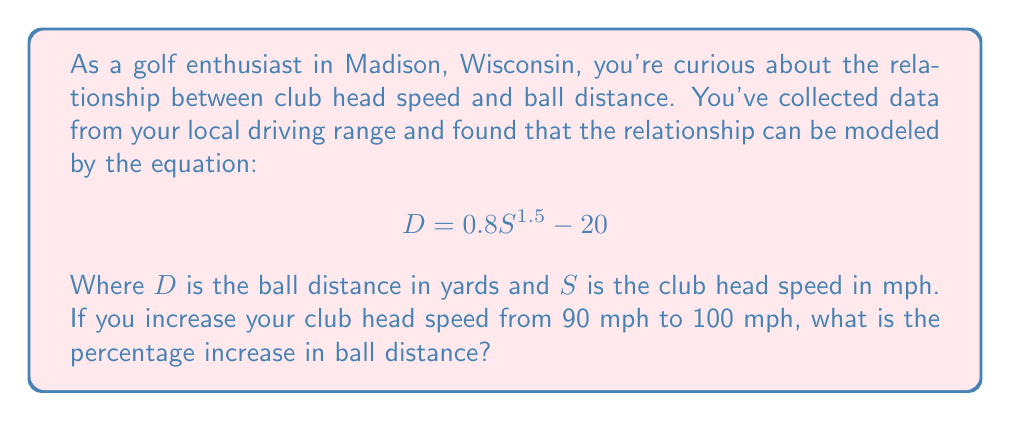Can you solve this math problem? Let's approach this step-by-step:

1) First, we need to calculate the ball distance for both speeds using the given equation:

   For 90 mph: $D_1 = 0.8(90)^{1.5} - 20$
   For 100 mph: $D_2 = 0.8(100)^{1.5} - 20$

2) Let's calculate $D_1$:
   $$D_1 = 0.8(90)^{1.5} - 20 = 0.8(853.17) - 20 = 682.54 - 20 = 662.54$$ yards

3) Now, let's calculate $D_2$:
   $$D_2 = 0.8(100)^{1.5} - 20 = 0.8(1000) - 20 = 800 - 20 = 780$$ yards

4) To find the percentage increase, we use the formula:
   $$\text{Percentage Increase} = \frac{\text{Increase}}{\text{Original Value}} \times 100\%$$

5) The increase in distance is $780 - 662.54 = 117.46$ yards

6) Therefore, the percentage increase is:
   $$\frac{117.46}{662.54} \times 100\% = 0.1773 \times 100\% = 17.73\%$$

Thus, increasing your club head speed from 90 mph to 100 mph results in a 17.73% increase in ball distance.
Answer: 17.73% 